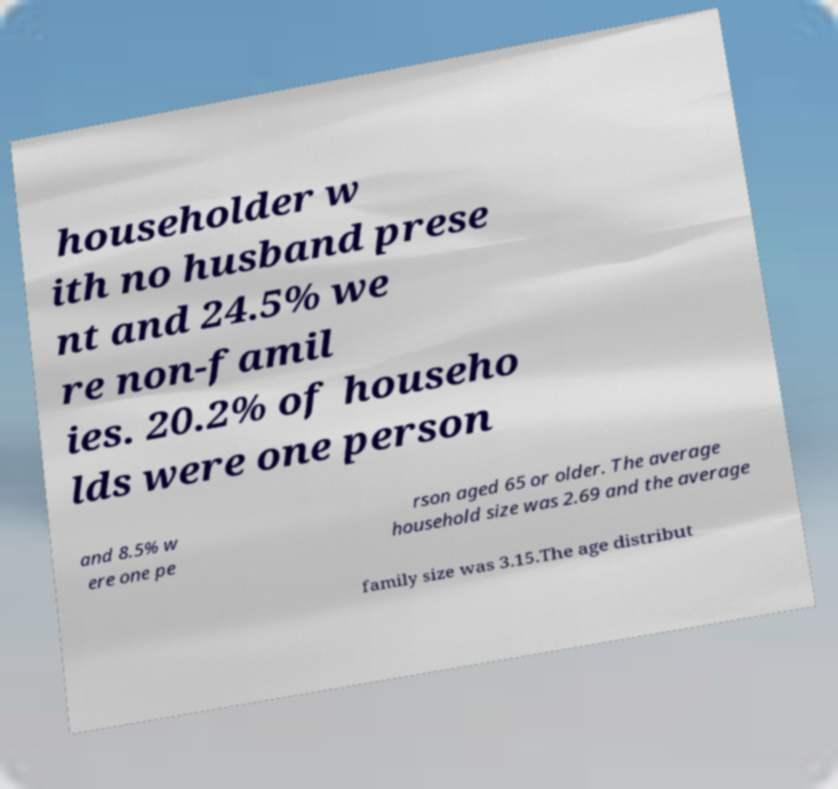There's text embedded in this image that I need extracted. Can you transcribe it verbatim? householder w ith no husband prese nt and 24.5% we re non-famil ies. 20.2% of househo lds were one person and 8.5% w ere one pe rson aged 65 or older. The average household size was 2.69 and the average family size was 3.15.The age distribut 